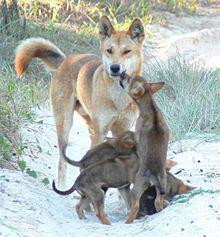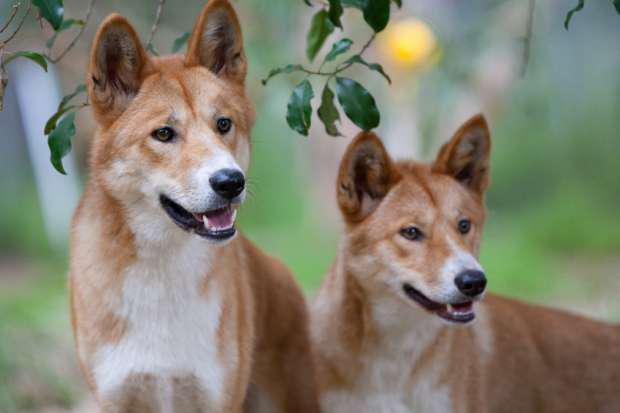The first image is the image on the left, the second image is the image on the right. Evaluate the accuracy of this statement regarding the images: "There's a total of 4 dogs on both images.". Is it true? Answer yes or no. No. 